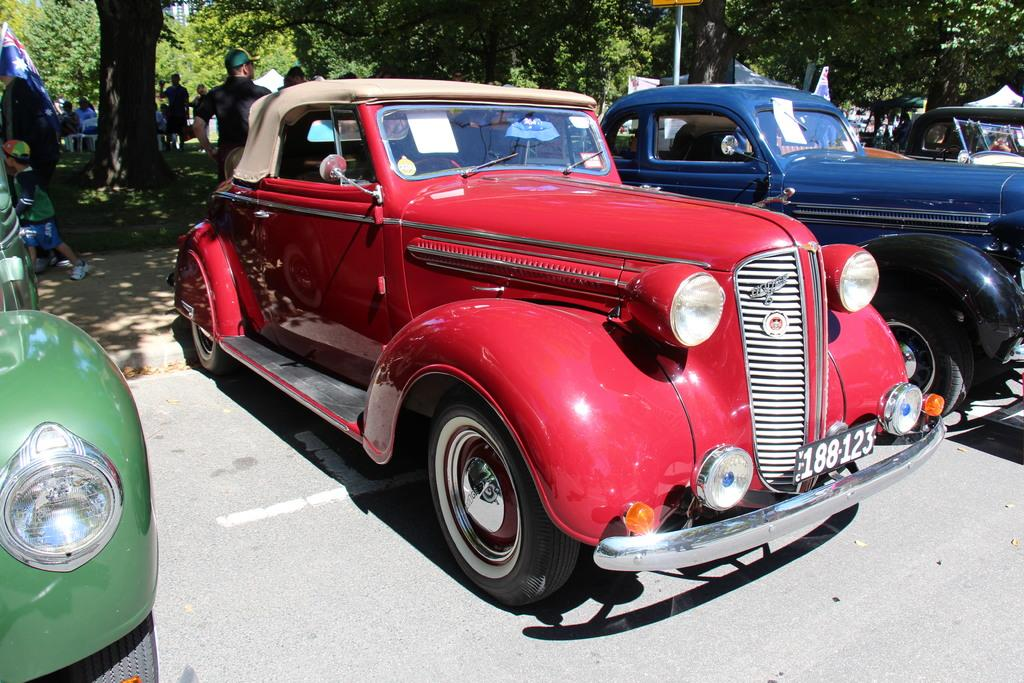What can be seen on the road in the image? There are vehicles parked on the road in the image. What is visible in the background of the image? In the background, there are trees, people, poles, tents, grass, and a flag. Can you describe the environment in the background? The background features a mix of natural elements like trees and grass, as well as man-made structures such as poles and tents. There is also a flag visible. What type of steam is coming from the vehicles in the image? There is no steam coming from the vehicles in the image. What is the chin of the person in the image doing? There is no person visible in the image, so it is impossible to determine what their chin is doing. 